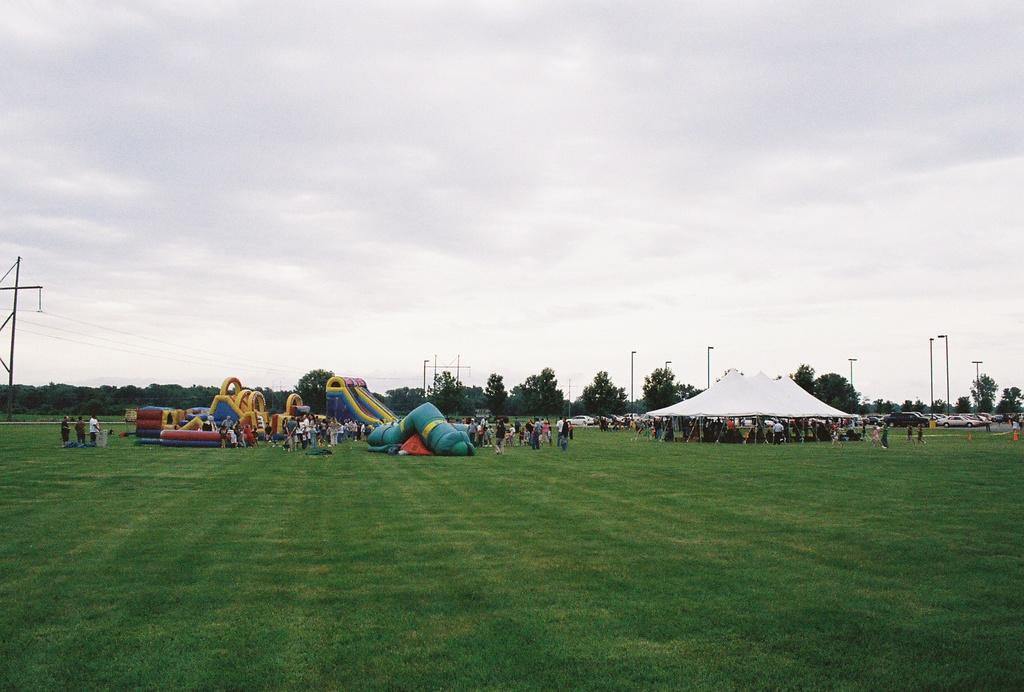Describe this image in one or two sentences. Sky is cloudy. Land is covered with grass. Far there are people, tent, light poles, vehicles, trees and Inflatables. 